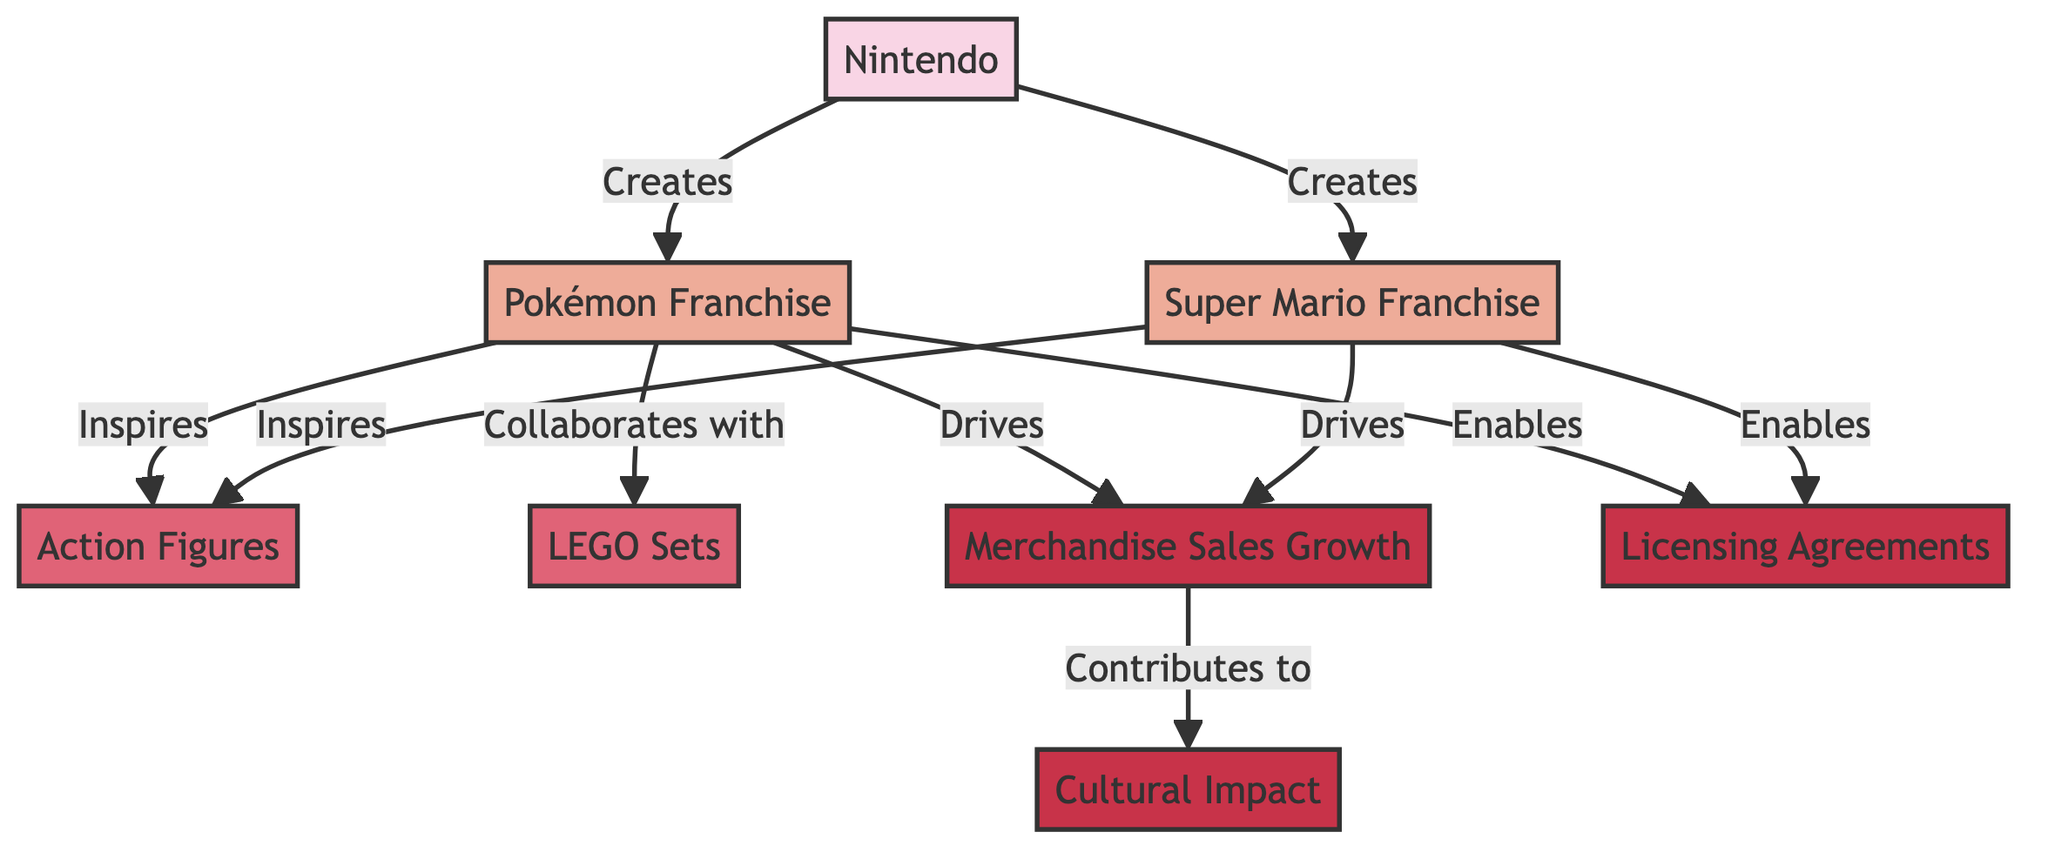What franchises are created by Nintendo? The edges from the "Nintendo" node lead to "Super Mario Franchise" and "Pokémon Franchise". Therefore, both of these franchises are the products of Nintendo's creation.
Answer: Super Mario Franchise and Pokémon Franchise Which franchise drives merchandise sales? There are two edges leading from the "Super Mario Franchise" and "Pokémon Franchise" nodes to "Merchandise Sales Growth". This shows that both franchises play a role in driving the growth of merchandise sales.
Answer: Super Mario Franchise and Pokémon Franchise How many action figure products are inspired by franchises? The diagram displays two edges from "Super Mario Franchise" and "Pokémon Franchise" to "Action Figures". This indicates that two franchises inspire action figure products.
Answer: 2 What does the edge from "Merchandise Sales" contribute to? The single edge from "Merchandise Sales" to "Cultural Impact" indicates that merchandise sales contribute to cultural impact, showing a direct relationship.
Answer: Cultural Impact Which company has licensing agreements with both franchises? The diagram shows edges from "Super Mario Franchise" and "Pokémon Franchise" to "Licensing Agreements", indicating that both franchises have licensing agreements, all originating from Nintendo.
Answer: Licensing Agreements What type of growth is indicated by the "Merchandise Sales" node? The diagram illustrates that "Merchandise Sales" is related to growth, especially since it states "Merchandise Sales Growth". This clearly defines the type of impact.
Answer: Growth Which products are associated with the Pokémon franchise? The edges lead from the "Pokémon Franchise" to both "Action Figures" and "LEGO Sets", indicating that these products are associated with the Pokémon franchise.
Answer: Action Figures and LEGO Sets How many nodes represent franchises in the graph? The graph has two franchise nodes: "Super Mario Franchise" and "Pokémon Franchise". Counting these nodes gives a total of two franchise representations.
Answer: 2 